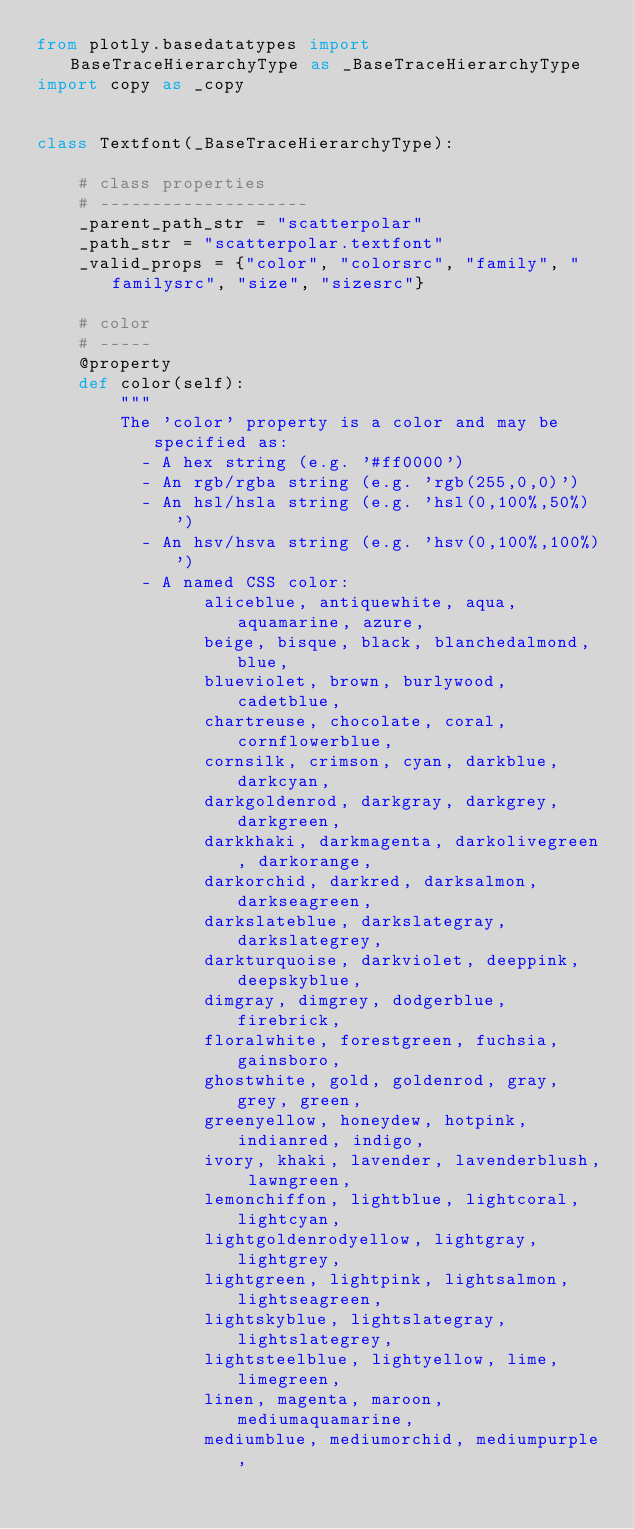Convert code to text. <code><loc_0><loc_0><loc_500><loc_500><_Python_>from plotly.basedatatypes import BaseTraceHierarchyType as _BaseTraceHierarchyType
import copy as _copy


class Textfont(_BaseTraceHierarchyType):

    # class properties
    # --------------------
    _parent_path_str = "scatterpolar"
    _path_str = "scatterpolar.textfont"
    _valid_props = {"color", "colorsrc", "family", "familysrc", "size", "sizesrc"}

    # color
    # -----
    @property
    def color(self):
        """
        The 'color' property is a color and may be specified as:
          - A hex string (e.g. '#ff0000')
          - An rgb/rgba string (e.g. 'rgb(255,0,0)')
          - An hsl/hsla string (e.g. 'hsl(0,100%,50%)')
          - An hsv/hsva string (e.g. 'hsv(0,100%,100%)')
          - A named CSS color:
                aliceblue, antiquewhite, aqua, aquamarine, azure,
                beige, bisque, black, blanchedalmond, blue,
                blueviolet, brown, burlywood, cadetblue,
                chartreuse, chocolate, coral, cornflowerblue,
                cornsilk, crimson, cyan, darkblue, darkcyan,
                darkgoldenrod, darkgray, darkgrey, darkgreen,
                darkkhaki, darkmagenta, darkolivegreen, darkorange,
                darkorchid, darkred, darksalmon, darkseagreen,
                darkslateblue, darkslategray, darkslategrey,
                darkturquoise, darkviolet, deeppink, deepskyblue,
                dimgray, dimgrey, dodgerblue, firebrick,
                floralwhite, forestgreen, fuchsia, gainsboro,
                ghostwhite, gold, goldenrod, gray, grey, green,
                greenyellow, honeydew, hotpink, indianred, indigo,
                ivory, khaki, lavender, lavenderblush, lawngreen,
                lemonchiffon, lightblue, lightcoral, lightcyan,
                lightgoldenrodyellow, lightgray, lightgrey,
                lightgreen, lightpink, lightsalmon, lightseagreen,
                lightskyblue, lightslategray, lightslategrey,
                lightsteelblue, lightyellow, lime, limegreen,
                linen, magenta, maroon, mediumaquamarine,
                mediumblue, mediumorchid, mediumpurple,</code> 